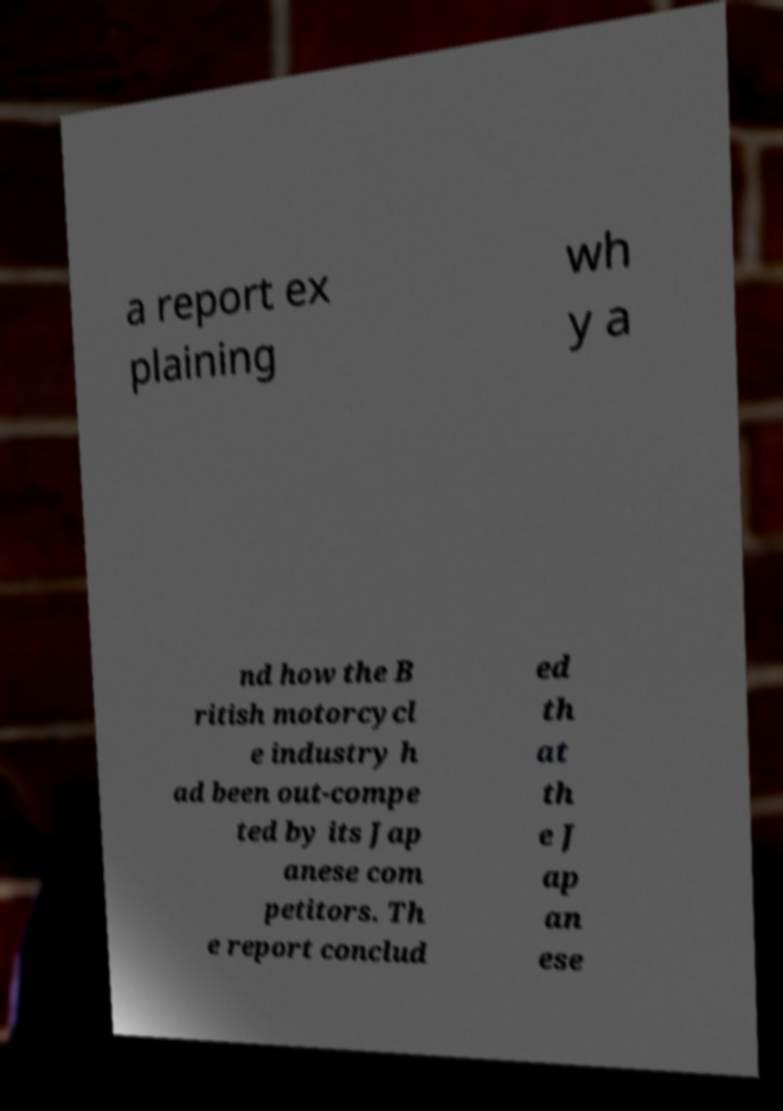What messages or text are displayed in this image? I need them in a readable, typed format. a report ex plaining wh y a nd how the B ritish motorcycl e industry h ad been out-compe ted by its Jap anese com petitors. Th e report conclud ed th at th e J ap an ese 